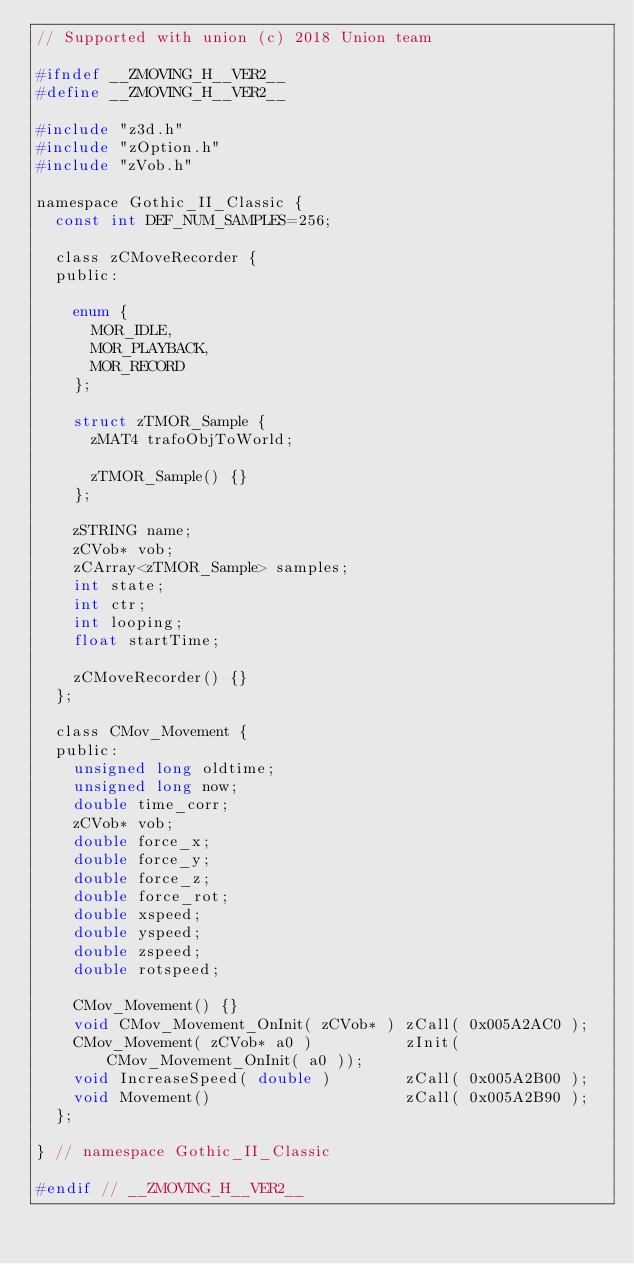Convert code to text. <code><loc_0><loc_0><loc_500><loc_500><_C_>// Supported with union (c) 2018 Union team

#ifndef __ZMOVING_H__VER2__
#define __ZMOVING_H__VER2__

#include "z3d.h"
#include "zOption.h"
#include "zVob.h"

namespace Gothic_II_Classic {
  const int DEF_NUM_SAMPLES=256;

  class zCMoveRecorder {
  public:

    enum {
      MOR_IDLE,
      MOR_PLAYBACK,
      MOR_RECORD
    };

    struct zTMOR_Sample {
      zMAT4 trafoObjToWorld;

      zTMOR_Sample() {}
    };

    zSTRING name;
    zCVob* vob;
    zCArray<zTMOR_Sample> samples;
    int state;
    int ctr;
    int looping;
    float startTime;

    zCMoveRecorder() {}
  };

  class CMov_Movement {
  public:
    unsigned long oldtime;
    unsigned long now;
    double time_corr;
    zCVob* vob;
    double force_x;
    double force_y;
    double force_z;
    double force_rot;
    double xspeed;
    double yspeed;
    double zspeed;
    double rotspeed;

    CMov_Movement() {}
    void CMov_Movement_OnInit( zCVob* ) zCall( 0x005A2AC0 );
    CMov_Movement( zCVob* a0 )          zInit( CMov_Movement_OnInit( a0 ));
    void IncreaseSpeed( double )        zCall( 0x005A2B00 );
    void Movement()                     zCall( 0x005A2B90 );
  };

} // namespace Gothic_II_Classic

#endif // __ZMOVING_H__VER2__</code> 